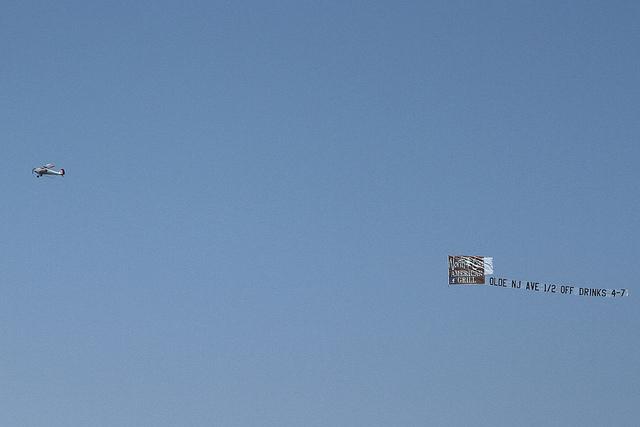Are all clouds gone?
Give a very brief answer. Yes. What does the sign say?
Answer briefly. Olde nj ave 1/2 off drinks 4-7. How many signs is the plane pulling?
Keep it brief. 1. Is it sunny out?
Concise answer only. Yes. What is the plane doing?
Concise answer only. Flying. What is behind the planes?
Short answer required. Banner. Sunny or overcast day?
Give a very brief answer. Sunny. Who sponsors this performer?
Quick response, please. American grill. Are there clouds in the sky?
Give a very brief answer. No. 